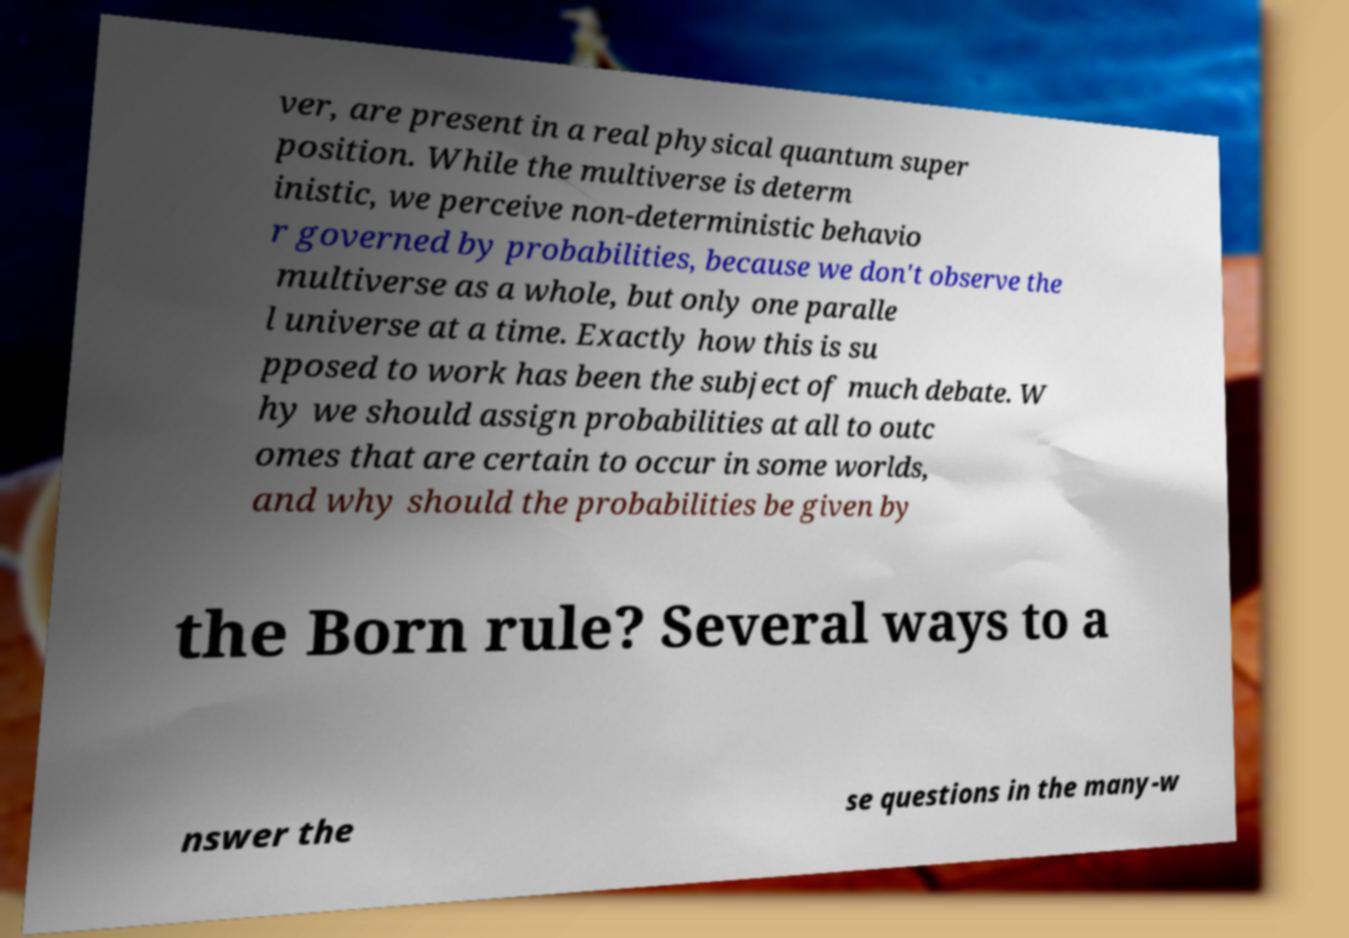Can you accurately transcribe the text from the provided image for me? ver, are present in a real physical quantum super position. While the multiverse is determ inistic, we perceive non-deterministic behavio r governed by probabilities, because we don't observe the multiverse as a whole, but only one paralle l universe at a time. Exactly how this is su pposed to work has been the subject of much debate. W hy we should assign probabilities at all to outc omes that are certain to occur in some worlds, and why should the probabilities be given by the Born rule? Several ways to a nswer the se questions in the many-w 